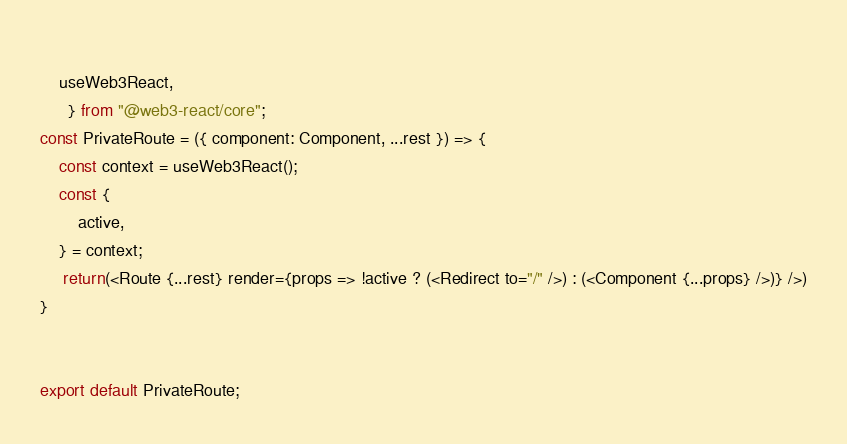Convert code to text. <code><loc_0><loc_0><loc_500><loc_500><_JavaScript_>    
    useWeb3React,
      } from "@web3-react/core";
const PrivateRoute = ({ component: Component, ...rest }) => {
    const context = useWeb3React();
    const { 
        active,
    } = context;
     return(<Route {...rest} render={props => !active ? (<Redirect to="/" />) : (<Component {...props} />)} />)
}


export default PrivateRoute;
</code> 